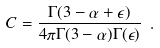<formula> <loc_0><loc_0><loc_500><loc_500>C = \frac { \Gamma ( 3 - \alpha + \epsilon ) } { 4 \pi \Gamma ( 3 - \alpha ) \Gamma ( \epsilon ) } \ .</formula> 